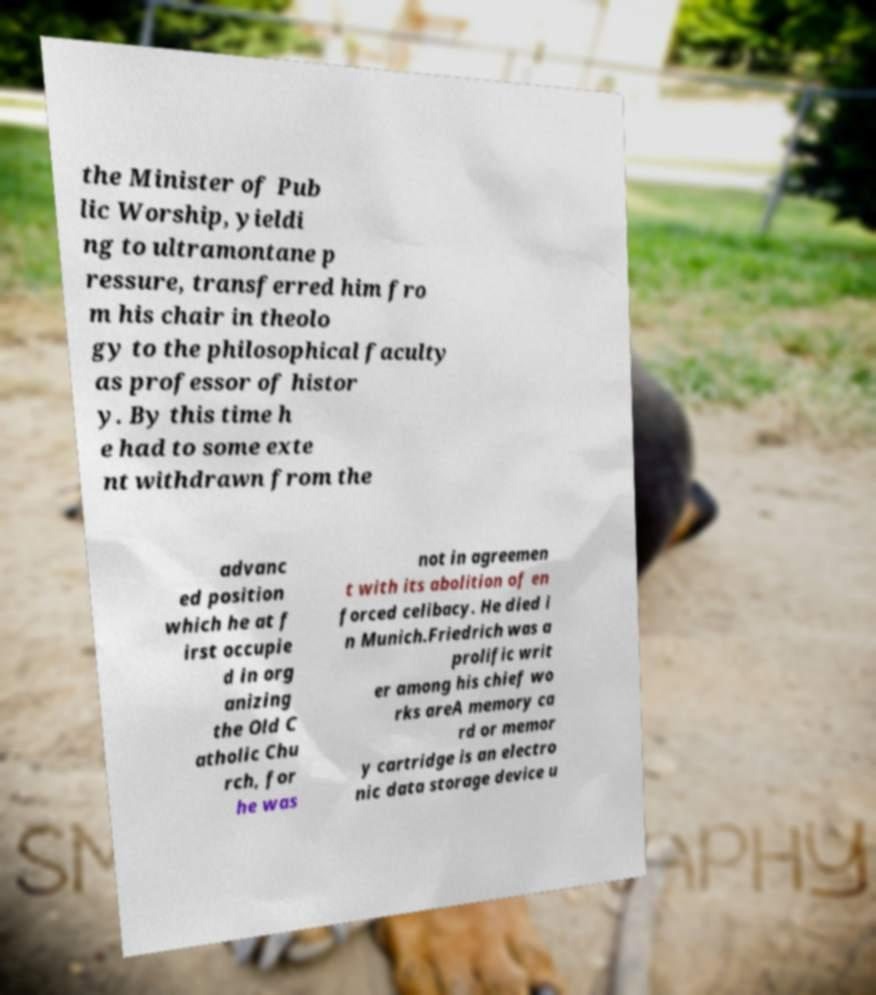Could you assist in decoding the text presented in this image and type it out clearly? the Minister of Pub lic Worship, yieldi ng to ultramontane p ressure, transferred him fro m his chair in theolo gy to the philosophical faculty as professor of histor y. By this time h e had to some exte nt withdrawn from the advanc ed position which he at f irst occupie d in org anizing the Old C atholic Chu rch, for he was not in agreemen t with its abolition of en forced celibacy. He died i n Munich.Friedrich was a prolific writ er among his chief wo rks areA memory ca rd or memor y cartridge is an electro nic data storage device u 